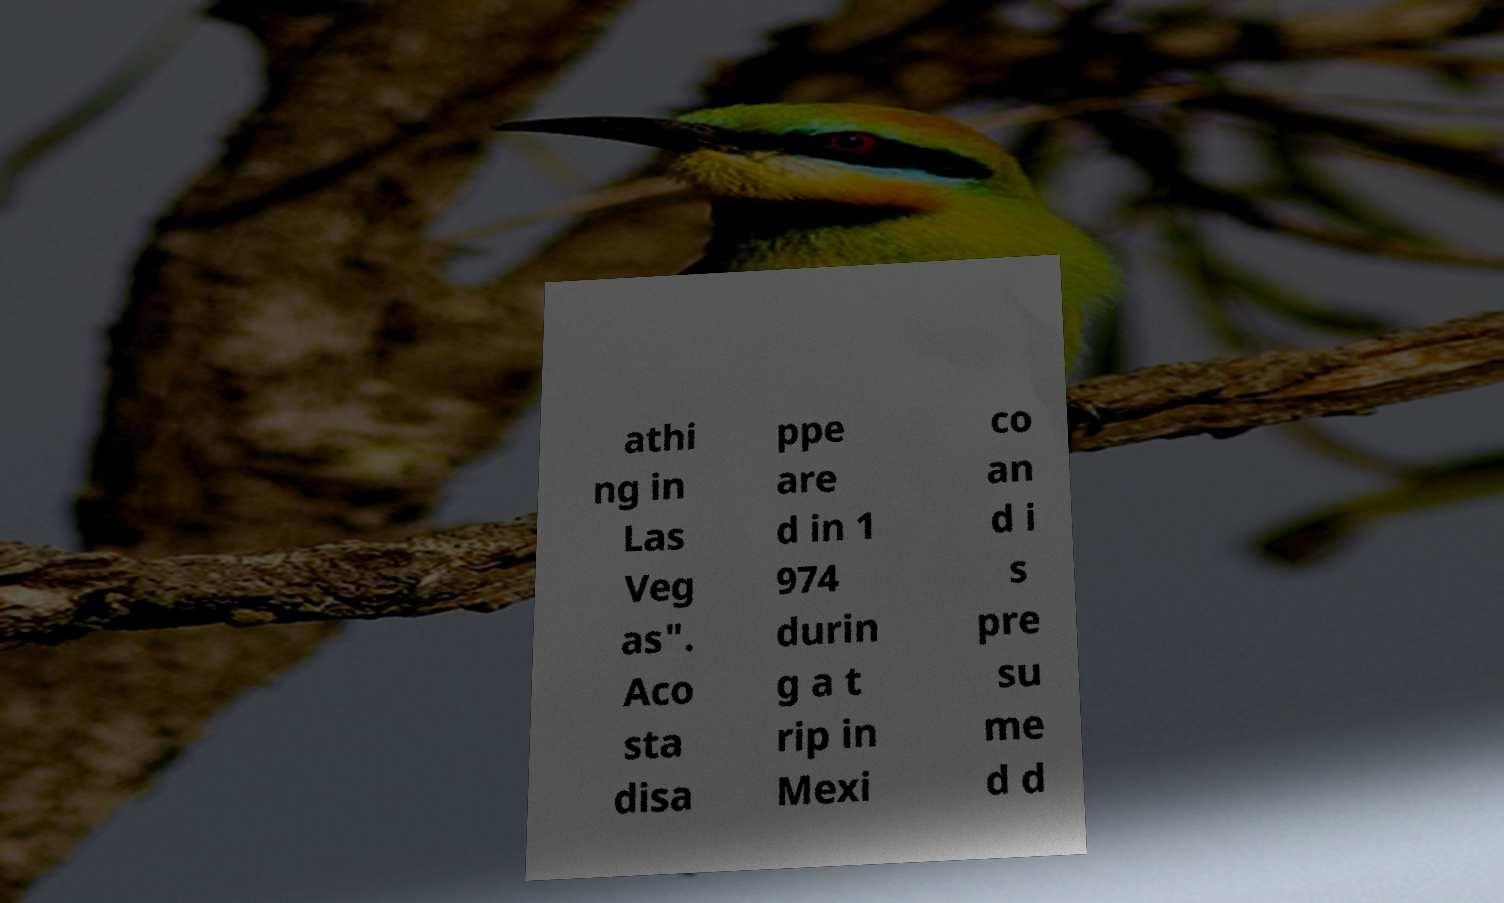Can you read and provide the text displayed in the image?This photo seems to have some interesting text. Can you extract and type it out for me? athi ng in Las Veg as". Aco sta disa ppe are d in 1 974 durin g a t rip in Mexi co an d i s pre su me d d 